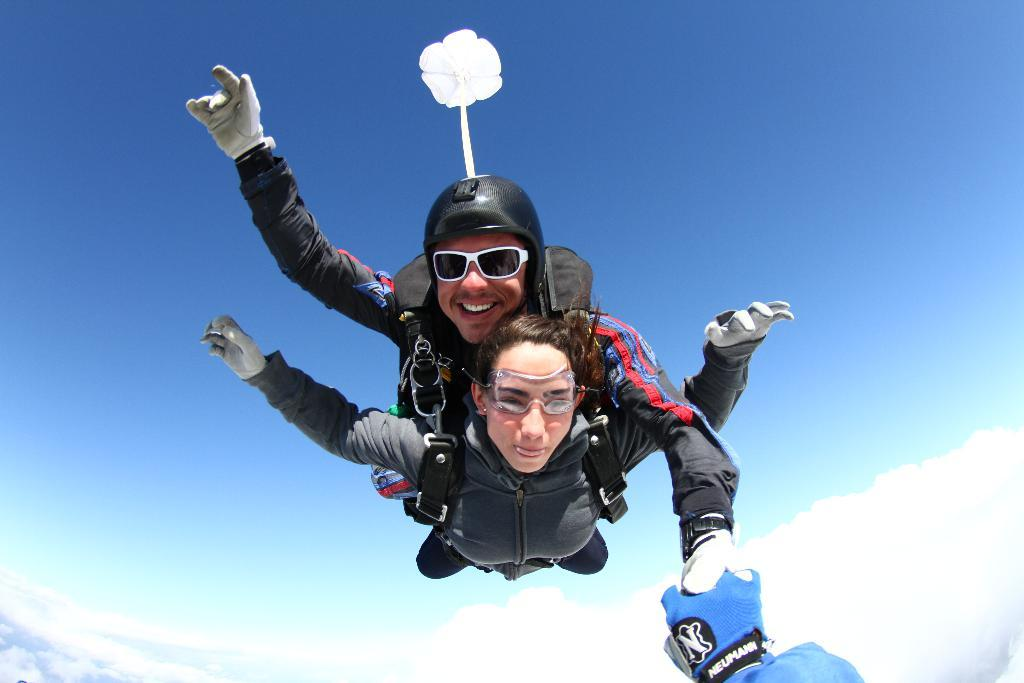Who are the people in the image? There is a man and a woman in the image. What are the man and woman doing in the image? Both the man and woman are skydiving. What can be seen in the background of the image? There is sky visible in the background of the image, and there are clouds present. What holiday is being celebrated in the image? There is no indication of a holiday being celebrated in the image. How many people are in the group skydiving in the image? There are only two people in the image, the man and woman, and they are skydiving individually, not as a group. 